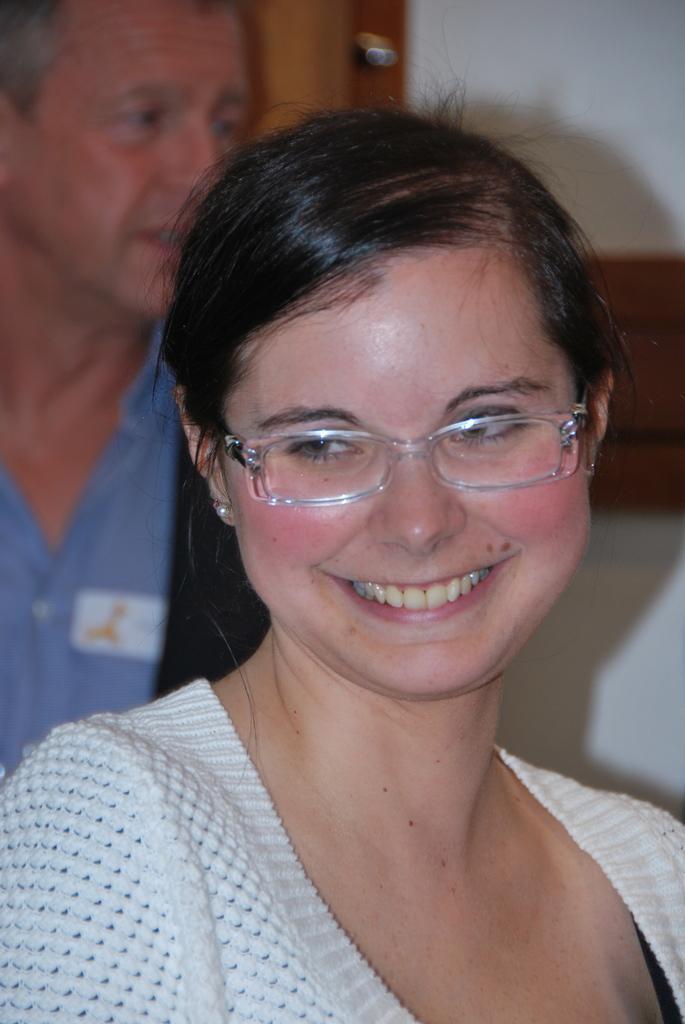Describe this image in one or two sentences. This woman is smiling and wore spectacles. Back Side we can see a man. 